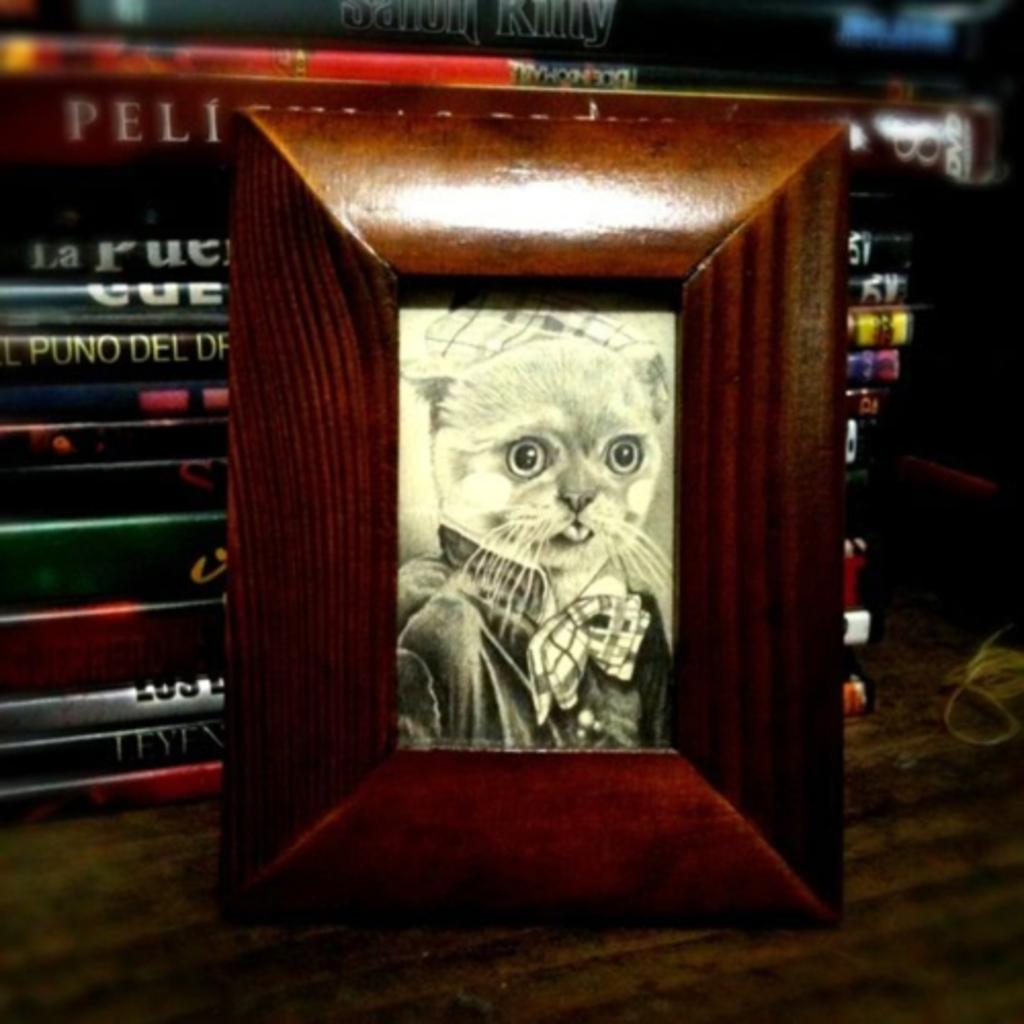What is the main subject of the image? There is a frame in the image. What can be seen inside the frame? There is a cat in the frame. What is visible in the background of the image? There are books in the background of the image. What is the price of the butter in the image? There is no butter present in the image, so it is not possible to determine its price. 